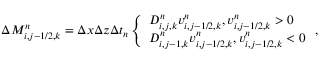Convert formula to latex. <formula><loc_0><loc_0><loc_500><loc_500>\begin{array} { r } { \Delta M _ { i , j - 1 / 2 , k } ^ { n } = \Delta x \Delta z \Delta t _ { n } \left \{ \begin{array} { l l } { D _ { i , j , k } ^ { n } v _ { i , j - 1 / 2 , k } ^ { n } , v _ { i , j - 1 / 2 , k } ^ { n } > 0 } \\ { D _ { i , j - 1 , k } ^ { n } v _ { i , j - 1 / 2 , k } ^ { n } , v _ { i , j - 1 / 2 , k } ^ { n } < 0 } \end{array} , } \end{array}</formula> 